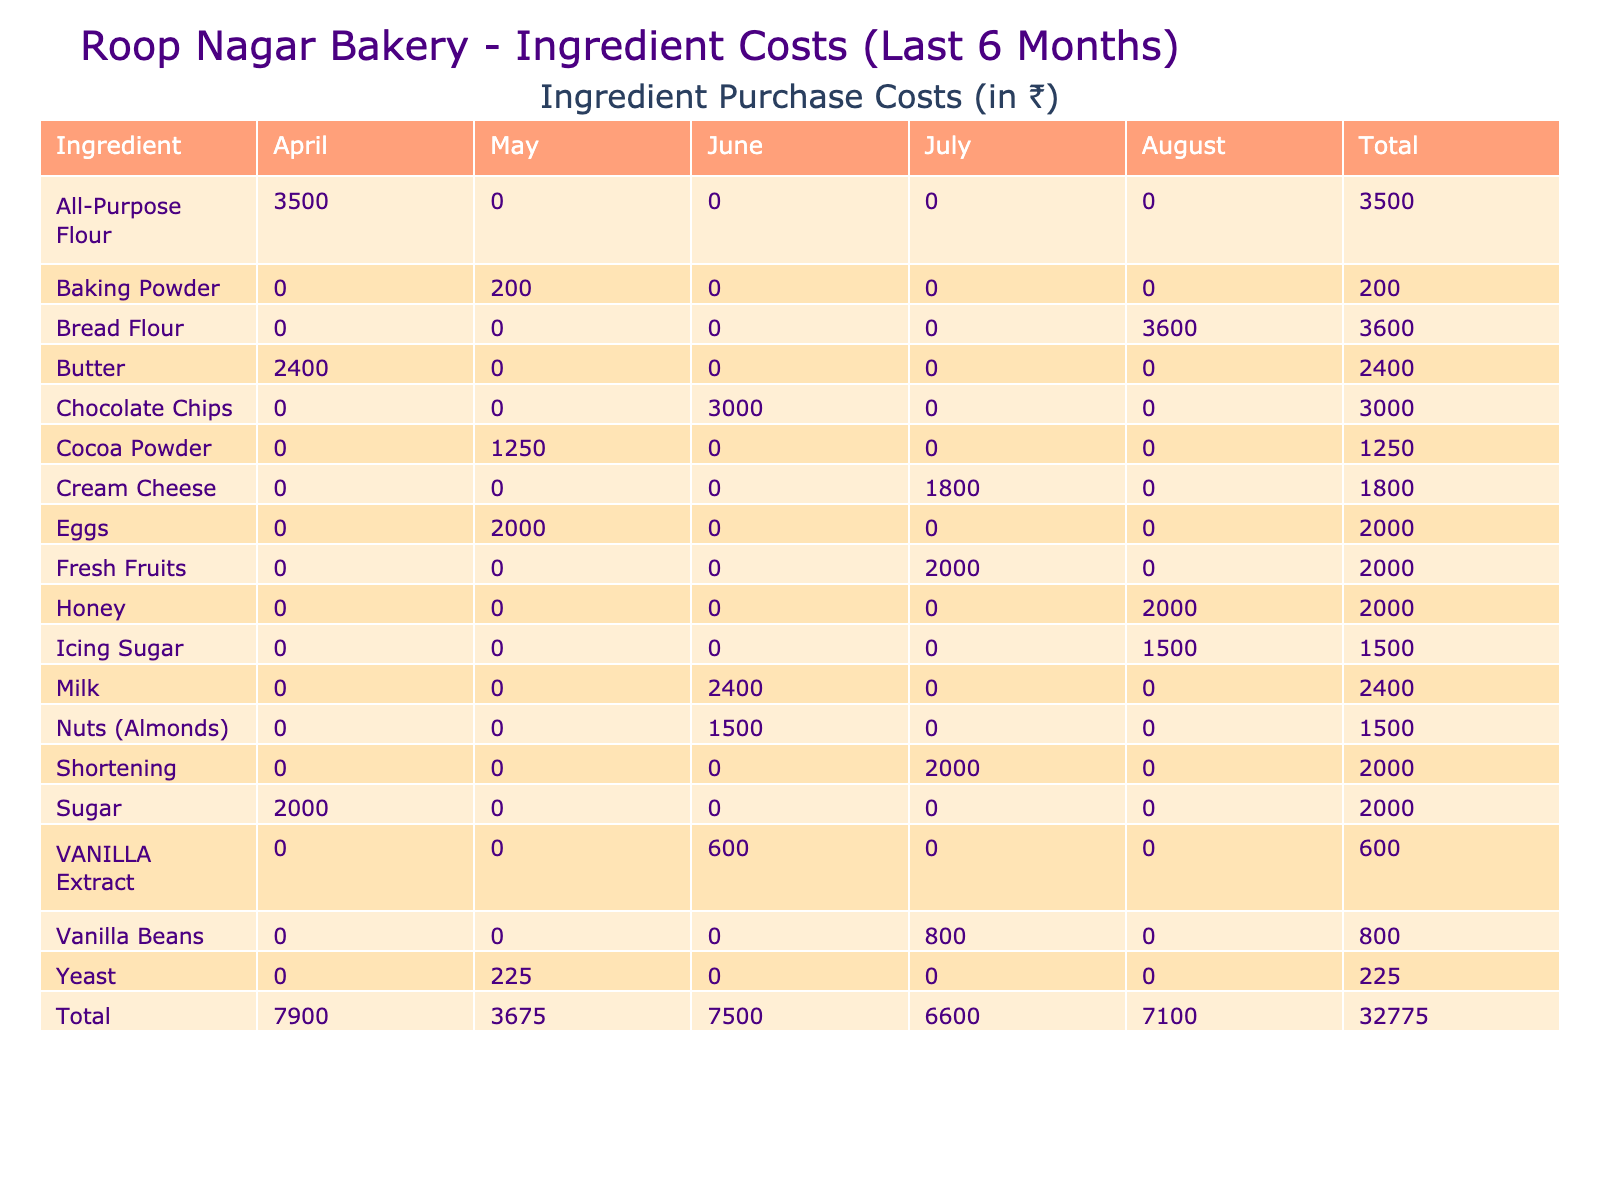What was the total cost of Sugar in May? According to the table, the total cost of Sugar in May is listed under the "May" column next to Sugar. The value is 2000.
Answer: 2000 Which ingredient had the highest total cost over the last six months? By examining the totals in the "Total" row, Vanilla Beans have the highest cost, which is 800.
Answer: Vanilla Beans What is the total amount spent on Butter and Chocolate Chips combined? The total cost for Butter is 2400 and for Chocolate Chips is 3000. Adding these amounts together gives 2400 + 3000 = 5400.
Answer: 5400 Did the total cost of All-Purpose Flour increase or decrease from April to August? The total cost for All-Purpose Flour is 3500 in April and does not appear in subsequent months; therefore, it decreased to 0 in August.
Answer: Decreased What is the average cost per unit of Fresh Fruits over the months it was purchased? Fresh Fruits were purchased only in July, where the cost per unit is 100. Since there is only one month, the average is 100.
Answer: 100 How much more did we spend on Vanilla Beans compared to Baking Powder over the last six months? Vanilla Beans cost 800 in July, and Baking Powder cost 200 in May. The difference is 800 - 200 = 600.
Answer: 600 What percentage of the total costs was attributed to Milk throughout the six months? The total costs sum up to 25,000 (from the totals), and Milk costs 2400. The percentage is (2400 / 25000) * 100 = 9.6%.
Answer: 9.6% How many ingredients have a total cost higher than 2000? From the total costs listed, the ingredients with totals greater than 2000 are Butter, Chocolate Chips, All-Purpose Flour, and so on. Counting these gives a total of 6 ingredients.
Answer: 6 Which month had the highest total cost for ingredient purchases? Adding the total costs for each month gives: April (3500 + 2000 + 2400 = 7900), May (2000 + 225 + 200 + 1250 = 3675), June (600 + 3000 + 2400 + 1500 = 5400), July (2000 + 800 + 1800 + 2000 = 6200), August (1500 + 3600 + 2000 = 7100). The highest is April with 7900.
Answer: April How many total units of Yeast were purchased in May? According to the table, 15 units of Yeast were purchased in May.
Answer: 15 